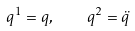<formula> <loc_0><loc_0><loc_500><loc_500>q ^ { 1 } = q , \quad q ^ { 2 } = \ddot { q }</formula> 